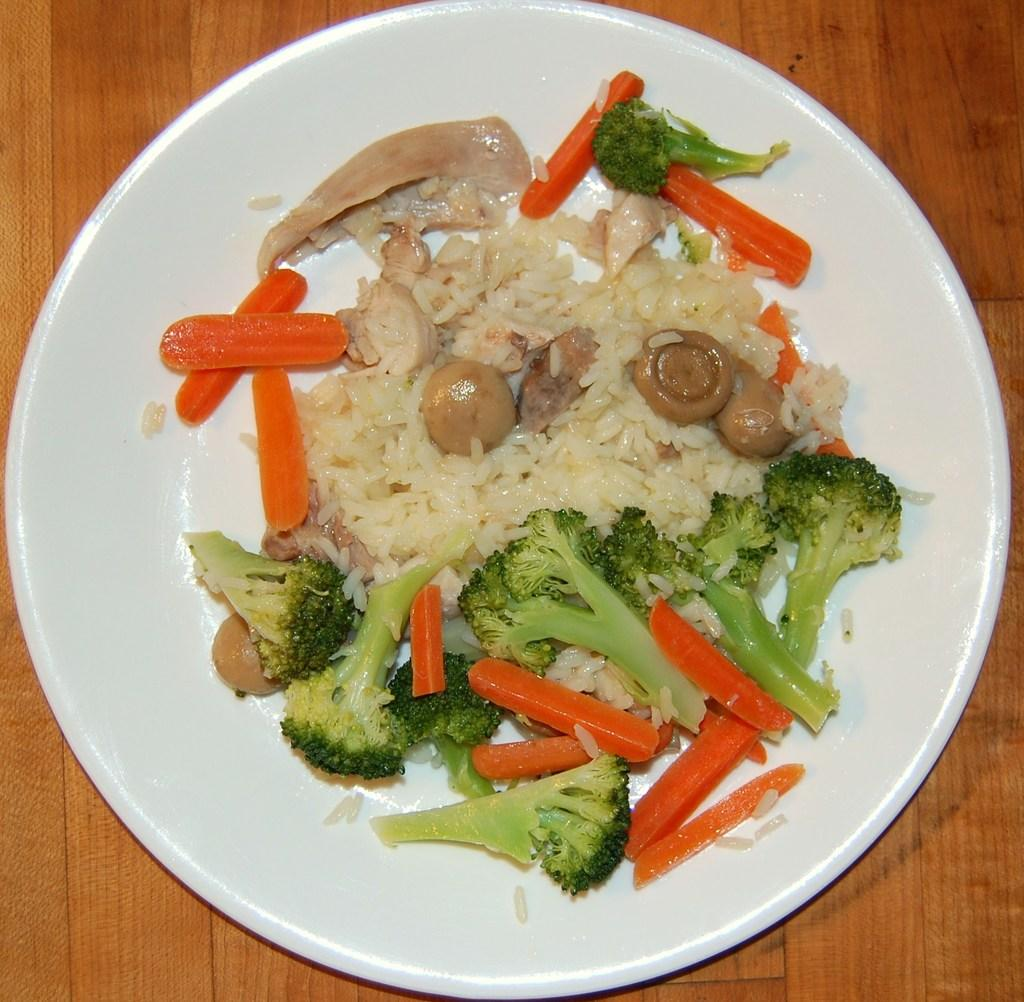What is on the plate that is visible in the image? There are pieces of carrot, pieces of broccoli, and rice in the plate. What type of vegetable can be seen in the plate? Both carrot and broccoli are visible in the plate. What is the base material of the plate? The plate is not described in the facts, but there is a wooden surface at the bottom of the image. What type of brain is visible on the wooden surface in the image? There is no brain visible on the wooden surface in the image. 